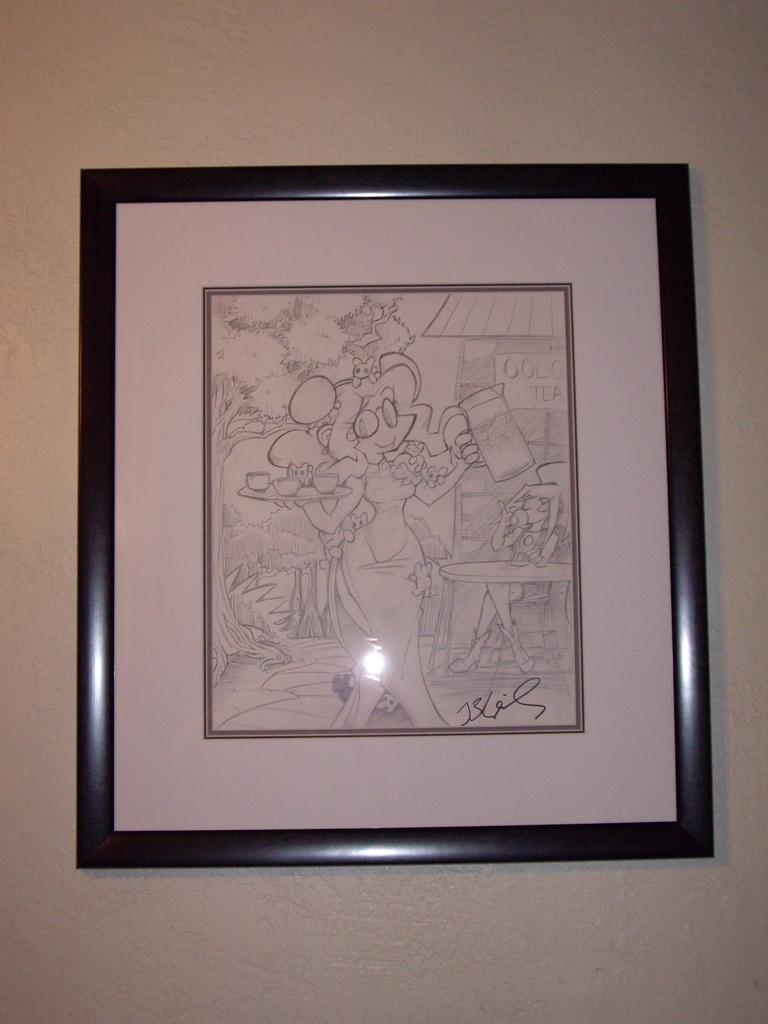What is the main object in the image? There is a frame in the image. Where is the frame located? The frame is attached to the wall. What type of copper dinosaur can be seen driving a car in the image? There is no copper dinosaur or car present in the image; it only features a frame attached to the wall. 